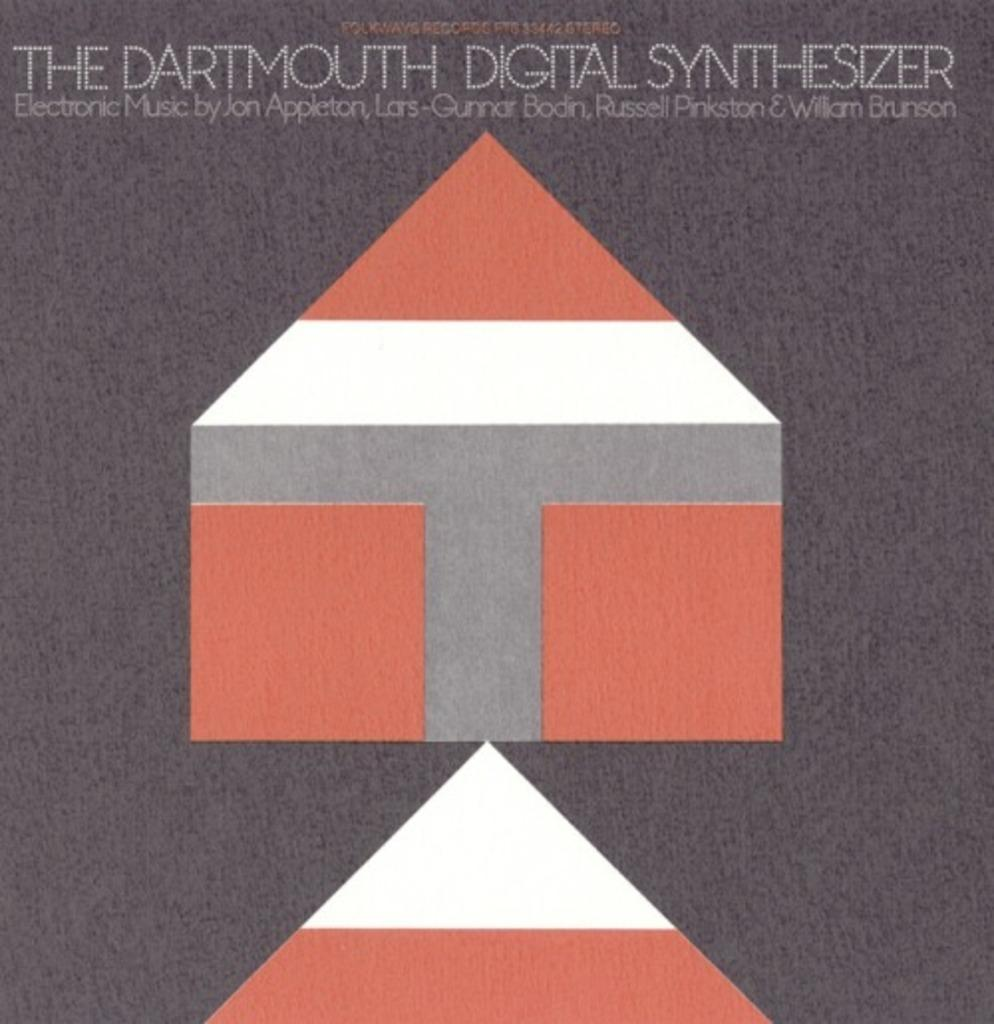What type of visual is depicted in the image? The image is a poster. Can you describe the design of the poster? The poster has a design, but the specifics are not mentioned in the facts. What information is conveyed through text on the poster? There is text written on the poster, but the content is not specified in the facts. What type of reward is shown on the poster for catching the train on time? There is no mention of a train, time, or reward in the provided facts, so this question cannot be answered based on the information given. 